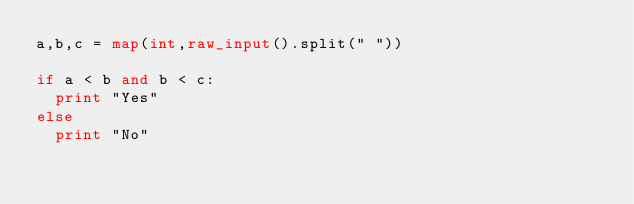<code> <loc_0><loc_0><loc_500><loc_500><_Python_>a,b,c = map(int,raw_input().split(" "))

if a < b and b < c:
  print "Yes"
else
  print "No"</code> 